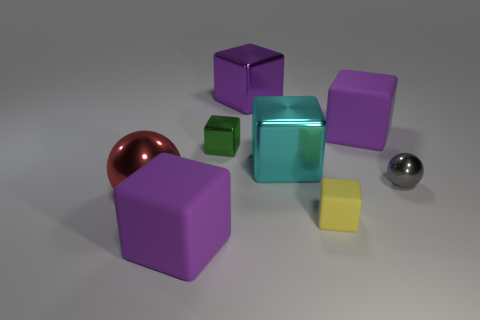Subtract all blue balls. How many purple cubes are left? 3 Subtract 1 cubes. How many cubes are left? 5 Subtract all yellow cubes. How many cubes are left? 5 Subtract all large cyan blocks. How many blocks are left? 5 Subtract all gray cubes. Subtract all cyan cylinders. How many cubes are left? 6 Add 1 shiny things. How many objects exist? 9 Subtract all blocks. How many objects are left? 2 Subtract 0 purple balls. How many objects are left? 8 Subtract all cyan objects. Subtract all green blocks. How many objects are left? 6 Add 1 small rubber cubes. How many small rubber cubes are left? 2 